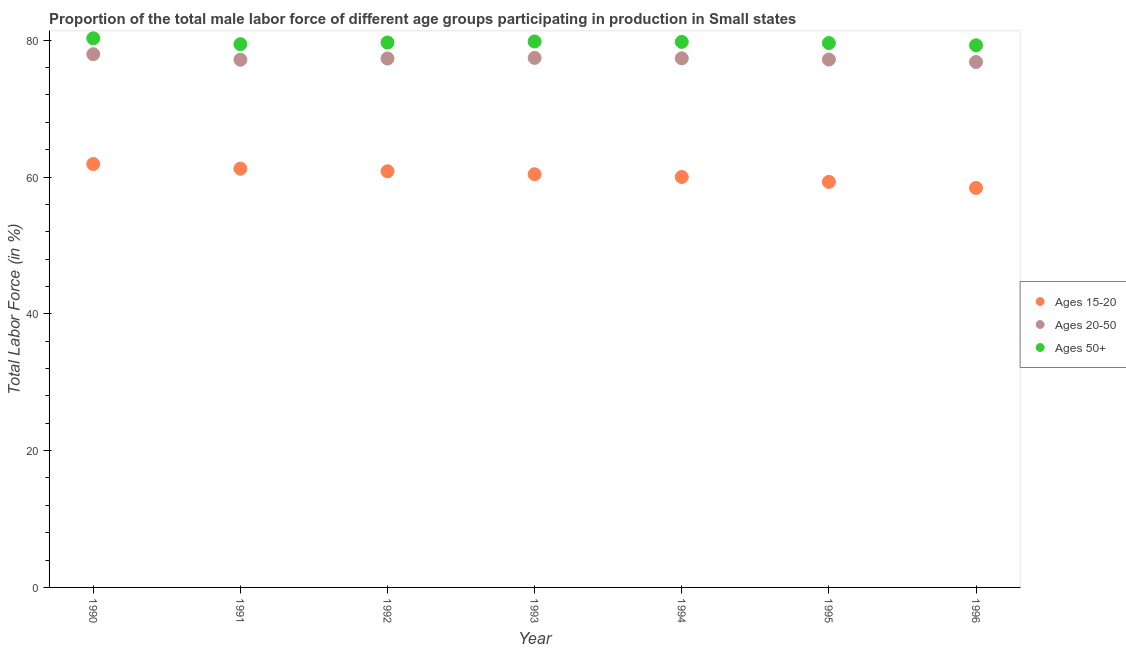What is the percentage of male labor force within the age group 20-50 in 1994?
Give a very brief answer. 77.35. Across all years, what is the maximum percentage of male labor force within the age group 20-50?
Ensure brevity in your answer.  77.96. Across all years, what is the minimum percentage of male labor force above age 50?
Ensure brevity in your answer.  79.26. In which year was the percentage of male labor force within the age group 20-50 minimum?
Your answer should be very brief. 1996. What is the total percentage of male labor force within the age group 20-50 in the graph?
Your response must be concise. 541.21. What is the difference between the percentage of male labor force within the age group 20-50 in 1990 and that in 1995?
Your answer should be compact. 0.78. What is the difference between the percentage of male labor force within the age group 15-20 in 1990 and the percentage of male labor force above age 50 in 1996?
Ensure brevity in your answer.  -17.36. What is the average percentage of male labor force within the age group 15-20 per year?
Your response must be concise. 60.3. In the year 1994, what is the difference between the percentage of male labor force within the age group 20-50 and percentage of male labor force within the age group 15-20?
Your answer should be very brief. 17.34. What is the ratio of the percentage of male labor force within the age group 20-50 in 1992 to that in 1996?
Make the answer very short. 1.01. Is the percentage of male labor force within the age group 15-20 in 1990 less than that in 1993?
Provide a succinct answer. No. What is the difference between the highest and the second highest percentage of male labor force above age 50?
Make the answer very short. 0.46. What is the difference between the highest and the lowest percentage of male labor force within the age group 20-50?
Ensure brevity in your answer.  1.14. How many dotlines are there?
Provide a short and direct response. 3. How many years are there in the graph?
Offer a terse response. 7. How are the legend labels stacked?
Make the answer very short. Vertical. What is the title of the graph?
Offer a terse response. Proportion of the total male labor force of different age groups participating in production in Small states. Does "Ages 20-50" appear as one of the legend labels in the graph?
Provide a short and direct response. Yes. What is the label or title of the X-axis?
Provide a succinct answer. Year. What is the label or title of the Y-axis?
Your answer should be compact. Total Labor Force (in %). What is the Total Labor Force (in %) in Ages 15-20 in 1990?
Offer a very short reply. 61.9. What is the Total Labor Force (in %) in Ages 20-50 in 1990?
Provide a short and direct response. 77.96. What is the Total Labor Force (in %) of Ages 50+ in 1990?
Make the answer very short. 80.28. What is the Total Labor Force (in %) in Ages 15-20 in 1991?
Offer a very short reply. 61.22. What is the Total Labor Force (in %) of Ages 20-50 in 1991?
Ensure brevity in your answer.  77.15. What is the Total Labor Force (in %) in Ages 50+ in 1991?
Offer a terse response. 79.43. What is the Total Labor Force (in %) in Ages 15-20 in 1992?
Give a very brief answer. 60.84. What is the Total Labor Force (in %) of Ages 20-50 in 1992?
Your answer should be compact. 77.33. What is the Total Labor Force (in %) of Ages 50+ in 1992?
Give a very brief answer. 79.66. What is the Total Labor Force (in %) of Ages 15-20 in 1993?
Provide a short and direct response. 60.41. What is the Total Labor Force (in %) in Ages 20-50 in 1993?
Offer a terse response. 77.42. What is the Total Labor Force (in %) in Ages 50+ in 1993?
Ensure brevity in your answer.  79.82. What is the Total Labor Force (in %) in Ages 15-20 in 1994?
Your answer should be very brief. 60.01. What is the Total Labor Force (in %) in Ages 20-50 in 1994?
Ensure brevity in your answer.  77.35. What is the Total Labor Force (in %) in Ages 50+ in 1994?
Provide a succinct answer. 79.76. What is the Total Labor Force (in %) of Ages 15-20 in 1995?
Your response must be concise. 59.29. What is the Total Labor Force (in %) of Ages 20-50 in 1995?
Your answer should be very brief. 77.18. What is the Total Labor Force (in %) in Ages 50+ in 1995?
Make the answer very short. 79.59. What is the Total Labor Force (in %) of Ages 15-20 in 1996?
Give a very brief answer. 58.4. What is the Total Labor Force (in %) in Ages 20-50 in 1996?
Offer a very short reply. 76.82. What is the Total Labor Force (in %) of Ages 50+ in 1996?
Provide a short and direct response. 79.26. Across all years, what is the maximum Total Labor Force (in %) of Ages 15-20?
Ensure brevity in your answer.  61.9. Across all years, what is the maximum Total Labor Force (in %) in Ages 20-50?
Ensure brevity in your answer.  77.96. Across all years, what is the maximum Total Labor Force (in %) of Ages 50+?
Give a very brief answer. 80.28. Across all years, what is the minimum Total Labor Force (in %) of Ages 15-20?
Ensure brevity in your answer.  58.4. Across all years, what is the minimum Total Labor Force (in %) in Ages 20-50?
Provide a succinct answer. 76.82. Across all years, what is the minimum Total Labor Force (in %) in Ages 50+?
Your response must be concise. 79.26. What is the total Total Labor Force (in %) in Ages 15-20 in the graph?
Ensure brevity in your answer.  422.08. What is the total Total Labor Force (in %) of Ages 20-50 in the graph?
Offer a very short reply. 541.21. What is the total Total Labor Force (in %) in Ages 50+ in the graph?
Your response must be concise. 557.8. What is the difference between the Total Labor Force (in %) in Ages 15-20 in 1990 and that in 1991?
Provide a short and direct response. 0.69. What is the difference between the Total Labor Force (in %) in Ages 20-50 in 1990 and that in 1991?
Keep it short and to the point. 0.81. What is the difference between the Total Labor Force (in %) in Ages 50+ in 1990 and that in 1991?
Offer a very short reply. 0.86. What is the difference between the Total Labor Force (in %) in Ages 15-20 in 1990 and that in 1992?
Your response must be concise. 1.06. What is the difference between the Total Labor Force (in %) in Ages 20-50 in 1990 and that in 1992?
Provide a short and direct response. 0.63. What is the difference between the Total Labor Force (in %) of Ages 50+ in 1990 and that in 1992?
Make the answer very short. 0.62. What is the difference between the Total Labor Force (in %) of Ages 15-20 in 1990 and that in 1993?
Provide a short and direct response. 1.5. What is the difference between the Total Labor Force (in %) in Ages 20-50 in 1990 and that in 1993?
Provide a succinct answer. 0.54. What is the difference between the Total Labor Force (in %) in Ages 50+ in 1990 and that in 1993?
Your answer should be very brief. 0.46. What is the difference between the Total Labor Force (in %) of Ages 15-20 in 1990 and that in 1994?
Keep it short and to the point. 1.9. What is the difference between the Total Labor Force (in %) of Ages 20-50 in 1990 and that in 1994?
Provide a short and direct response. 0.61. What is the difference between the Total Labor Force (in %) in Ages 50+ in 1990 and that in 1994?
Give a very brief answer. 0.52. What is the difference between the Total Labor Force (in %) of Ages 15-20 in 1990 and that in 1995?
Your answer should be very brief. 2.61. What is the difference between the Total Labor Force (in %) in Ages 20-50 in 1990 and that in 1995?
Make the answer very short. 0.78. What is the difference between the Total Labor Force (in %) in Ages 50+ in 1990 and that in 1995?
Your response must be concise. 0.69. What is the difference between the Total Labor Force (in %) of Ages 15-20 in 1990 and that in 1996?
Provide a short and direct response. 3.5. What is the difference between the Total Labor Force (in %) in Ages 20-50 in 1990 and that in 1996?
Keep it short and to the point. 1.14. What is the difference between the Total Labor Force (in %) in Ages 50+ in 1990 and that in 1996?
Keep it short and to the point. 1.02. What is the difference between the Total Labor Force (in %) of Ages 15-20 in 1991 and that in 1992?
Give a very brief answer. 0.37. What is the difference between the Total Labor Force (in %) in Ages 20-50 in 1991 and that in 1992?
Make the answer very short. -0.18. What is the difference between the Total Labor Force (in %) of Ages 50+ in 1991 and that in 1992?
Your answer should be compact. -0.24. What is the difference between the Total Labor Force (in %) of Ages 15-20 in 1991 and that in 1993?
Keep it short and to the point. 0.81. What is the difference between the Total Labor Force (in %) in Ages 20-50 in 1991 and that in 1993?
Provide a succinct answer. -0.27. What is the difference between the Total Labor Force (in %) in Ages 50+ in 1991 and that in 1993?
Your answer should be compact. -0.39. What is the difference between the Total Labor Force (in %) of Ages 15-20 in 1991 and that in 1994?
Offer a terse response. 1.21. What is the difference between the Total Labor Force (in %) in Ages 20-50 in 1991 and that in 1994?
Offer a very short reply. -0.2. What is the difference between the Total Labor Force (in %) in Ages 50+ in 1991 and that in 1994?
Give a very brief answer. -0.33. What is the difference between the Total Labor Force (in %) in Ages 15-20 in 1991 and that in 1995?
Provide a short and direct response. 1.93. What is the difference between the Total Labor Force (in %) of Ages 20-50 in 1991 and that in 1995?
Provide a succinct answer. -0.03. What is the difference between the Total Labor Force (in %) of Ages 50+ in 1991 and that in 1995?
Provide a short and direct response. -0.16. What is the difference between the Total Labor Force (in %) in Ages 15-20 in 1991 and that in 1996?
Keep it short and to the point. 2.81. What is the difference between the Total Labor Force (in %) in Ages 20-50 in 1991 and that in 1996?
Your answer should be very brief. 0.33. What is the difference between the Total Labor Force (in %) in Ages 50+ in 1991 and that in 1996?
Give a very brief answer. 0.17. What is the difference between the Total Labor Force (in %) in Ages 15-20 in 1992 and that in 1993?
Your response must be concise. 0.43. What is the difference between the Total Labor Force (in %) of Ages 20-50 in 1992 and that in 1993?
Your answer should be very brief. -0.09. What is the difference between the Total Labor Force (in %) of Ages 50+ in 1992 and that in 1993?
Your answer should be very brief. -0.15. What is the difference between the Total Labor Force (in %) in Ages 15-20 in 1992 and that in 1994?
Give a very brief answer. 0.83. What is the difference between the Total Labor Force (in %) in Ages 20-50 in 1992 and that in 1994?
Offer a terse response. -0.02. What is the difference between the Total Labor Force (in %) of Ages 50+ in 1992 and that in 1994?
Your answer should be compact. -0.09. What is the difference between the Total Labor Force (in %) in Ages 15-20 in 1992 and that in 1995?
Make the answer very short. 1.55. What is the difference between the Total Labor Force (in %) in Ages 20-50 in 1992 and that in 1995?
Give a very brief answer. 0.15. What is the difference between the Total Labor Force (in %) in Ages 50+ in 1992 and that in 1995?
Provide a short and direct response. 0.08. What is the difference between the Total Labor Force (in %) of Ages 15-20 in 1992 and that in 1996?
Give a very brief answer. 2.44. What is the difference between the Total Labor Force (in %) of Ages 20-50 in 1992 and that in 1996?
Ensure brevity in your answer.  0.51. What is the difference between the Total Labor Force (in %) in Ages 50+ in 1992 and that in 1996?
Provide a short and direct response. 0.41. What is the difference between the Total Labor Force (in %) in Ages 15-20 in 1993 and that in 1994?
Offer a very short reply. 0.4. What is the difference between the Total Labor Force (in %) in Ages 20-50 in 1993 and that in 1994?
Keep it short and to the point. 0.07. What is the difference between the Total Labor Force (in %) in Ages 50+ in 1993 and that in 1994?
Make the answer very short. 0.06. What is the difference between the Total Labor Force (in %) in Ages 15-20 in 1993 and that in 1995?
Ensure brevity in your answer.  1.12. What is the difference between the Total Labor Force (in %) of Ages 20-50 in 1993 and that in 1995?
Make the answer very short. 0.24. What is the difference between the Total Labor Force (in %) of Ages 50+ in 1993 and that in 1995?
Offer a terse response. 0.23. What is the difference between the Total Labor Force (in %) in Ages 15-20 in 1993 and that in 1996?
Provide a short and direct response. 2.01. What is the difference between the Total Labor Force (in %) of Ages 20-50 in 1993 and that in 1996?
Offer a terse response. 0.6. What is the difference between the Total Labor Force (in %) of Ages 50+ in 1993 and that in 1996?
Provide a succinct answer. 0.56. What is the difference between the Total Labor Force (in %) of Ages 15-20 in 1994 and that in 1995?
Your answer should be very brief. 0.72. What is the difference between the Total Labor Force (in %) in Ages 20-50 in 1994 and that in 1995?
Your response must be concise. 0.17. What is the difference between the Total Labor Force (in %) of Ages 50+ in 1994 and that in 1995?
Offer a very short reply. 0.17. What is the difference between the Total Labor Force (in %) of Ages 15-20 in 1994 and that in 1996?
Your answer should be compact. 1.61. What is the difference between the Total Labor Force (in %) of Ages 20-50 in 1994 and that in 1996?
Your answer should be very brief. 0.53. What is the difference between the Total Labor Force (in %) of Ages 50+ in 1994 and that in 1996?
Your response must be concise. 0.5. What is the difference between the Total Labor Force (in %) in Ages 15-20 in 1995 and that in 1996?
Offer a terse response. 0.89. What is the difference between the Total Labor Force (in %) in Ages 20-50 in 1995 and that in 1996?
Ensure brevity in your answer.  0.36. What is the difference between the Total Labor Force (in %) of Ages 50+ in 1995 and that in 1996?
Make the answer very short. 0.33. What is the difference between the Total Labor Force (in %) of Ages 15-20 in 1990 and the Total Labor Force (in %) of Ages 20-50 in 1991?
Your answer should be compact. -15.25. What is the difference between the Total Labor Force (in %) in Ages 15-20 in 1990 and the Total Labor Force (in %) in Ages 50+ in 1991?
Your answer should be compact. -17.52. What is the difference between the Total Labor Force (in %) of Ages 20-50 in 1990 and the Total Labor Force (in %) of Ages 50+ in 1991?
Ensure brevity in your answer.  -1.47. What is the difference between the Total Labor Force (in %) in Ages 15-20 in 1990 and the Total Labor Force (in %) in Ages 20-50 in 1992?
Provide a short and direct response. -15.42. What is the difference between the Total Labor Force (in %) of Ages 15-20 in 1990 and the Total Labor Force (in %) of Ages 50+ in 1992?
Your response must be concise. -17.76. What is the difference between the Total Labor Force (in %) in Ages 20-50 in 1990 and the Total Labor Force (in %) in Ages 50+ in 1992?
Provide a succinct answer. -1.71. What is the difference between the Total Labor Force (in %) of Ages 15-20 in 1990 and the Total Labor Force (in %) of Ages 20-50 in 1993?
Provide a short and direct response. -15.51. What is the difference between the Total Labor Force (in %) in Ages 15-20 in 1990 and the Total Labor Force (in %) in Ages 50+ in 1993?
Offer a very short reply. -17.91. What is the difference between the Total Labor Force (in %) in Ages 20-50 in 1990 and the Total Labor Force (in %) in Ages 50+ in 1993?
Offer a terse response. -1.86. What is the difference between the Total Labor Force (in %) of Ages 15-20 in 1990 and the Total Labor Force (in %) of Ages 20-50 in 1994?
Offer a very short reply. -15.45. What is the difference between the Total Labor Force (in %) in Ages 15-20 in 1990 and the Total Labor Force (in %) in Ages 50+ in 1994?
Keep it short and to the point. -17.85. What is the difference between the Total Labor Force (in %) in Ages 20-50 in 1990 and the Total Labor Force (in %) in Ages 50+ in 1994?
Provide a succinct answer. -1.8. What is the difference between the Total Labor Force (in %) of Ages 15-20 in 1990 and the Total Labor Force (in %) of Ages 20-50 in 1995?
Ensure brevity in your answer.  -15.28. What is the difference between the Total Labor Force (in %) of Ages 15-20 in 1990 and the Total Labor Force (in %) of Ages 50+ in 1995?
Provide a succinct answer. -17.69. What is the difference between the Total Labor Force (in %) in Ages 20-50 in 1990 and the Total Labor Force (in %) in Ages 50+ in 1995?
Your response must be concise. -1.63. What is the difference between the Total Labor Force (in %) of Ages 15-20 in 1990 and the Total Labor Force (in %) of Ages 20-50 in 1996?
Offer a terse response. -14.92. What is the difference between the Total Labor Force (in %) of Ages 15-20 in 1990 and the Total Labor Force (in %) of Ages 50+ in 1996?
Provide a succinct answer. -17.36. What is the difference between the Total Labor Force (in %) of Ages 20-50 in 1990 and the Total Labor Force (in %) of Ages 50+ in 1996?
Provide a succinct answer. -1.3. What is the difference between the Total Labor Force (in %) of Ages 15-20 in 1991 and the Total Labor Force (in %) of Ages 20-50 in 1992?
Make the answer very short. -16.11. What is the difference between the Total Labor Force (in %) in Ages 15-20 in 1991 and the Total Labor Force (in %) in Ages 50+ in 1992?
Provide a succinct answer. -18.45. What is the difference between the Total Labor Force (in %) in Ages 20-50 in 1991 and the Total Labor Force (in %) in Ages 50+ in 1992?
Provide a succinct answer. -2.51. What is the difference between the Total Labor Force (in %) in Ages 15-20 in 1991 and the Total Labor Force (in %) in Ages 20-50 in 1993?
Your answer should be very brief. -16.2. What is the difference between the Total Labor Force (in %) in Ages 15-20 in 1991 and the Total Labor Force (in %) in Ages 50+ in 1993?
Keep it short and to the point. -18.6. What is the difference between the Total Labor Force (in %) in Ages 20-50 in 1991 and the Total Labor Force (in %) in Ages 50+ in 1993?
Provide a succinct answer. -2.67. What is the difference between the Total Labor Force (in %) of Ages 15-20 in 1991 and the Total Labor Force (in %) of Ages 20-50 in 1994?
Offer a very short reply. -16.13. What is the difference between the Total Labor Force (in %) of Ages 15-20 in 1991 and the Total Labor Force (in %) of Ages 50+ in 1994?
Keep it short and to the point. -18.54. What is the difference between the Total Labor Force (in %) of Ages 20-50 in 1991 and the Total Labor Force (in %) of Ages 50+ in 1994?
Keep it short and to the point. -2.61. What is the difference between the Total Labor Force (in %) of Ages 15-20 in 1991 and the Total Labor Force (in %) of Ages 20-50 in 1995?
Your answer should be compact. -15.96. What is the difference between the Total Labor Force (in %) of Ages 15-20 in 1991 and the Total Labor Force (in %) of Ages 50+ in 1995?
Keep it short and to the point. -18.37. What is the difference between the Total Labor Force (in %) of Ages 20-50 in 1991 and the Total Labor Force (in %) of Ages 50+ in 1995?
Your answer should be very brief. -2.44. What is the difference between the Total Labor Force (in %) in Ages 15-20 in 1991 and the Total Labor Force (in %) in Ages 20-50 in 1996?
Make the answer very short. -15.6. What is the difference between the Total Labor Force (in %) of Ages 15-20 in 1991 and the Total Labor Force (in %) of Ages 50+ in 1996?
Give a very brief answer. -18.04. What is the difference between the Total Labor Force (in %) of Ages 20-50 in 1991 and the Total Labor Force (in %) of Ages 50+ in 1996?
Offer a very short reply. -2.11. What is the difference between the Total Labor Force (in %) in Ages 15-20 in 1992 and the Total Labor Force (in %) in Ages 20-50 in 1993?
Provide a succinct answer. -16.58. What is the difference between the Total Labor Force (in %) of Ages 15-20 in 1992 and the Total Labor Force (in %) of Ages 50+ in 1993?
Provide a succinct answer. -18.98. What is the difference between the Total Labor Force (in %) of Ages 20-50 in 1992 and the Total Labor Force (in %) of Ages 50+ in 1993?
Offer a terse response. -2.49. What is the difference between the Total Labor Force (in %) in Ages 15-20 in 1992 and the Total Labor Force (in %) in Ages 20-50 in 1994?
Ensure brevity in your answer.  -16.51. What is the difference between the Total Labor Force (in %) of Ages 15-20 in 1992 and the Total Labor Force (in %) of Ages 50+ in 1994?
Your answer should be very brief. -18.92. What is the difference between the Total Labor Force (in %) of Ages 20-50 in 1992 and the Total Labor Force (in %) of Ages 50+ in 1994?
Your answer should be compact. -2.43. What is the difference between the Total Labor Force (in %) in Ages 15-20 in 1992 and the Total Labor Force (in %) in Ages 20-50 in 1995?
Provide a succinct answer. -16.34. What is the difference between the Total Labor Force (in %) of Ages 15-20 in 1992 and the Total Labor Force (in %) of Ages 50+ in 1995?
Provide a short and direct response. -18.75. What is the difference between the Total Labor Force (in %) in Ages 20-50 in 1992 and the Total Labor Force (in %) in Ages 50+ in 1995?
Provide a succinct answer. -2.26. What is the difference between the Total Labor Force (in %) of Ages 15-20 in 1992 and the Total Labor Force (in %) of Ages 20-50 in 1996?
Your answer should be compact. -15.98. What is the difference between the Total Labor Force (in %) of Ages 15-20 in 1992 and the Total Labor Force (in %) of Ages 50+ in 1996?
Your answer should be compact. -18.42. What is the difference between the Total Labor Force (in %) of Ages 20-50 in 1992 and the Total Labor Force (in %) of Ages 50+ in 1996?
Provide a short and direct response. -1.93. What is the difference between the Total Labor Force (in %) in Ages 15-20 in 1993 and the Total Labor Force (in %) in Ages 20-50 in 1994?
Make the answer very short. -16.94. What is the difference between the Total Labor Force (in %) in Ages 15-20 in 1993 and the Total Labor Force (in %) in Ages 50+ in 1994?
Ensure brevity in your answer.  -19.35. What is the difference between the Total Labor Force (in %) in Ages 20-50 in 1993 and the Total Labor Force (in %) in Ages 50+ in 1994?
Your response must be concise. -2.34. What is the difference between the Total Labor Force (in %) in Ages 15-20 in 1993 and the Total Labor Force (in %) in Ages 20-50 in 1995?
Offer a very short reply. -16.77. What is the difference between the Total Labor Force (in %) of Ages 15-20 in 1993 and the Total Labor Force (in %) of Ages 50+ in 1995?
Offer a very short reply. -19.18. What is the difference between the Total Labor Force (in %) of Ages 20-50 in 1993 and the Total Labor Force (in %) of Ages 50+ in 1995?
Offer a very short reply. -2.17. What is the difference between the Total Labor Force (in %) in Ages 15-20 in 1993 and the Total Labor Force (in %) in Ages 20-50 in 1996?
Your answer should be very brief. -16.41. What is the difference between the Total Labor Force (in %) of Ages 15-20 in 1993 and the Total Labor Force (in %) of Ages 50+ in 1996?
Offer a terse response. -18.85. What is the difference between the Total Labor Force (in %) of Ages 20-50 in 1993 and the Total Labor Force (in %) of Ages 50+ in 1996?
Ensure brevity in your answer.  -1.84. What is the difference between the Total Labor Force (in %) of Ages 15-20 in 1994 and the Total Labor Force (in %) of Ages 20-50 in 1995?
Your answer should be very brief. -17.17. What is the difference between the Total Labor Force (in %) in Ages 15-20 in 1994 and the Total Labor Force (in %) in Ages 50+ in 1995?
Offer a very short reply. -19.58. What is the difference between the Total Labor Force (in %) in Ages 20-50 in 1994 and the Total Labor Force (in %) in Ages 50+ in 1995?
Offer a very short reply. -2.24. What is the difference between the Total Labor Force (in %) of Ages 15-20 in 1994 and the Total Labor Force (in %) of Ages 20-50 in 1996?
Offer a terse response. -16.81. What is the difference between the Total Labor Force (in %) of Ages 15-20 in 1994 and the Total Labor Force (in %) of Ages 50+ in 1996?
Provide a succinct answer. -19.25. What is the difference between the Total Labor Force (in %) of Ages 20-50 in 1994 and the Total Labor Force (in %) of Ages 50+ in 1996?
Provide a short and direct response. -1.91. What is the difference between the Total Labor Force (in %) of Ages 15-20 in 1995 and the Total Labor Force (in %) of Ages 20-50 in 1996?
Ensure brevity in your answer.  -17.53. What is the difference between the Total Labor Force (in %) in Ages 15-20 in 1995 and the Total Labor Force (in %) in Ages 50+ in 1996?
Keep it short and to the point. -19.97. What is the difference between the Total Labor Force (in %) of Ages 20-50 in 1995 and the Total Labor Force (in %) of Ages 50+ in 1996?
Offer a terse response. -2.08. What is the average Total Labor Force (in %) in Ages 15-20 per year?
Your answer should be very brief. 60.3. What is the average Total Labor Force (in %) of Ages 20-50 per year?
Your response must be concise. 77.32. What is the average Total Labor Force (in %) in Ages 50+ per year?
Provide a short and direct response. 79.69. In the year 1990, what is the difference between the Total Labor Force (in %) in Ages 15-20 and Total Labor Force (in %) in Ages 20-50?
Give a very brief answer. -16.05. In the year 1990, what is the difference between the Total Labor Force (in %) of Ages 15-20 and Total Labor Force (in %) of Ages 50+?
Your answer should be compact. -18.38. In the year 1990, what is the difference between the Total Labor Force (in %) of Ages 20-50 and Total Labor Force (in %) of Ages 50+?
Your answer should be very brief. -2.33. In the year 1991, what is the difference between the Total Labor Force (in %) in Ages 15-20 and Total Labor Force (in %) in Ages 20-50?
Make the answer very short. -15.93. In the year 1991, what is the difference between the Total Labor Force (in %) in Ages 15-20 and Total Labor Force (in %) in Ages 50+?
Offer a terse response. -18.21. In the year 1991, what is the difference between the Total Labor Force (in %) of Ages 20-50 and Total Labor Force (in %) of Ages 50+?
Provide a short and direct response. -2.27. In the year 1992, what is the difference between the Total Labor Force (in %) of Ages 15-20 and Total Labor Force (in %) of Ages 20-50?
Provide a succinct answer. -16.49. In the year 1992, what is the difference between the Total Labor Force (in %) of Ages 15-20 and Total Labor Force (in %) of Ages 50+?
Give a very brief answer. -18.82. In the year 1992, what is the difference between the Total Labor Force (in %) in Ages 20-50 and Total Labor Force (in %) in Ages 50+?
Offer a very short reply. -2.34. In the year 1993, what is the difference between the Total Labor Force (in %) of Ages 15-20 and Total Labor Force (in %) of Ages 20-50?
Ensure brevity in your answer.  -17.01. In the year 1993, what is the difference between the Total Labor Force (in %) in Ages 15-20 and Total Labor Force (in %) in Ages 50+?
Provide a short and direct response. -19.41. In the year 1993, what is the difference between the Total Labor Force (in %) in Ages 20-50 and Total Labor Force (in %) in Ages 50+?
Offer a terse response. -2.4. In the year 1994, what is the difference between the Total Labor Force (in %) of Ages 15-20 and Total Labor Force (in %) of Ages 20-50?
Your response must be concise. -17.34. In the year 1994, what is the difference between the Total Labor Force (in %) in Ages 15-20 and Total Labor Force (in %) in Ages 50+?
Provide a succinct answer. -19.75. In the year 1994, what is the difference between the Total Labor Force (in %) in Ages 20-50 and Total Labor Force (in %) in Ages 50+?
Make the answer very short. -2.41. In the year 1995, what is the difference between the Total Labor Force (in %) in Ages 15-20 and Total Labor Force (in %) in Ages 20-50?
Ensure brevity in your answer.  -17.89. In the year 1995, what is the difference between the Total Labor Force (in %) of Ages 15-20 and Total Labor Force (in %) of Ages 50+?
Provide a short and direct response. -20.3. In the year 1995, what is the difference between the Total Labor Force (in %) of Ages 20-50 and Total Labor Force (in %) of Ages 50+?
Ensure brevity in your answer.  -2.41. In the year 1996, what is the difference between the Total Labor Force (in %) of Ages 15-20 and Total Labor Force (in %) of Ages 20-50?
Offer a terse response. -18.42. In the year 1996, what is the difference between the Total Labor Force (in %) in Ages 15-20 and Total Labor Force (in %) in Ages 50+?
Your answer should be very brief. -20.86. In the year 1996, what is the difference between the Total Labor Force (in %) in Ages 20-50 and Total Labor Force (in %) in Ages 50+?
Offer a very short reply. -2.44. What is the ratio of the Total Labor Force (in %) of Ages 15-20 in 1990 to that in 1991?
Make the answer very short. 1.01. What is the ratio of the Total Labor Force (in %) in Ages 20-50 in 1990 to that in 1991?
Provide a succinct answer. 1.01. What is the ratio of the Total Labor Force (in %) of Ages 50+ in 1990 to that in 1991?
Give a very brief answer. 1.01. What is the ratio of the Total Labor Force (in %) in Ages 15-20 in 1990 to that in 1992?
Offer a very short reply. 1.02. What is the ratio of the Total Labor Force (in %) of Ages 50+ in 1990 to that in 1992?
Give a very brief answer. 1.01. What is the ratio of the Total Labor Force (in %) of Ages 15-20 in 1990 to that in 1993?
Give a very brief answer. 1.02. What is the ratio of the Total Labor Force (in %) in Ages 20-50 in 1990 to that in 1993?
Offer a terse response. 1.01. What is the ratio of the Total Labor Force (in %) of Ages 15-20 in 1990 to that in 1994?
Ensure brevity in your answer.  1.03. What is the ratio of the Total Labor Force (in %) in Ages 20-50 in 1990 to that in 1994?
Provide a succinct answer. 1.01. What is the ratio of the Total Labor Force (in %) of Ages 50+ in 1990 to that in 1994?
Your answer should be compact. 1.01. What is the ratio of the Total Labor Force (in %) in Ages 15-20 in 1990 to that in 1995?
Your response must be concise. 1.04. What is the ratio of the Total Labor Force (in %) of Ages 20-50 in 1990 to that in 1995?
Provide a succinct answer. 1.01. What is the ratio of the Total Labor Force (in %) of Ages 50+ in 1990 to that in 1995?
Your answer should be very brief. 1.01. What is the ratio of the Total Labor Force (in %) of Ages 15-20 in 1990 to that in 1996?
Your answer should be compact. 1.06. What is the ratio of the Total Labor Force (in %) in Ages 20-50 in 1990 to that in 1996?
Offer a terse response. 1.01. What is the ratio of the Total Labor Force (in %) in Ages 50+ in 1990 to that in 1996?
Provide a succinct answer. 1.01. What is the ratio of the Total Labor Force (in %) of Ages 15-20 in 1991 to that in 1992?
Your answer should be compact. 1.01. What is the ratio of the Total Labor Force (in %) of Ages 20-50 in 1991 to that in 1992?
Provide a short and direct response. 1. What is the ratio of the Total Labor Force (in %) in Ages 50+ in 1991 to that in 1992?
Give a very brief answer. 1. What is the ratio of the Total Labor Force (in %) in Ages 15-20 in 1991 to that in 1993?
Ensure brevity in your answer.  1.01. What is the ratio of the Total Labor Force (in %) in Ages 20-50 in 1991 to that in 1993?
Your answer should be very brief. 1. What is the ratio of the Total Labor Force (in %) in Ages 50+ in 1991 to that in 1993?
Your answer should be very brief. 1. What is the ratio of the Total Labor Force (in %) of Ages 15-20 in 1991 to that in 1994?
Offer a terse response. 1.02. What is the ratio of the Total Labor Force (in %) of Ages 20-50 in 1991 to that in 1994?
Provide a succinct answer. 1. What is the ratio of the Total Labor Force (in %) of Ages 15-20 in 1991 to that in 1995?
Your response must be concise. 1.03. What is the ratio of the Total Labor Force (in %) in Ages 15-20 in 1991 to that in 1996?
Your answer should be compact. 1.05. What is the ratio of the Total Labor Force (in %) of Ages 20-50 in 1991 to that in 1996?
Your answer should be compact. 1. What is the ratio of the Total Labor Force (in %) in Ages 15-20 in 1992 to that in 1993?
Keep it short and to the point. 1.01. What is the ratio of the Total Labor Force (in %) in Ages 20-50 in 1992 to that in 1993?
Offer a terse response. 1. What is the ratio of the Total Labor Force (in %) in Ages 50+ in 1992 to that in 1993?
Provide a short and direct response. 1. What is the ratio of the Total Labor Force (in %) of Ages 15-20 in 1992 to that in 1994?
Ensure brevity in your answer.  1.01. What is the ratio of the Total Labor Force (in %) in Ages 20-50 in 1992 to that in 1994?
Your answer should be very brief. 1. What is the ratio of the Total Labor Force (in %) in Ages 15-20 in 1992 to that in 1995?
Your answer should be compact. 1.03. What is the ratio of the Total Labor Force (in %) in Ages 20-50 in 1992 to that in 1995?
Make the answer very short. 1. What is the ratio of the Total Labor Force (in %) of Ages 50+ in 1992 to that in 1995?
Your answer should be compact. 1. What is the ratio of the Total Labor Force (in %) in Ages 15-20 in 1992 to that in 1996?
Offer a terse response. 1.04. What is the ratio of the Total Labor Force (in %) of Ages 20-50 in 1992 to that in 1996?
Give a very brief answer. 1.01. What is the ratio of the Total Labor Force (in %) in Ages 50+ in 1992 to that in 1996?
Provide a short and direct response. 1.01. What is the ratio of the Total Labor Force (in %) of Ages 20-50 in 1993 to that in 1994?
Offer a very short reply. 1. What is the ratio of the Total Labor Force (in %) of Ages 50+ in 1993 to that in 1994?
Provide a succinct answer. 1. What is the ratio of the Total Labor Force (in %) of Ages 15-20 in 1993 to that in 1995?
Give a very brief answer. 1.02. What is the ratio of the Total Labor Force (in %) of Ages 50+ in 1993 to that in 1995?
Your answer should be compact. 1. What is the ratio of the Total Labor Force (in %) in Ages 15-20 in 1993 to that in 1996?
Offer a very short reply. 1.03. What is the ratio of the Total Labor Force (in %) of Ages 50+ in 1993 to that in 1996?
Keep it short and to the point. 1.01. What is the ratio of the Total Labor Force (in %) in Ages 15-20 in 1994 to that in 1995?
Provide a short and direct response. 1.01. What is the ratio of the Total Labor Force (in %) of Ages 20-50 in 1994 to that in 1995?
Your response must be concise. 1. What is the ratio of the Total Labor Force (in %) in Ages 50+ in 1994 to that in 1995?
Give a very brief answer. 1. What is the ratio of the Total Labor Force (in %) in Ages 15-20 in 1994 to that in 1996?
Provide a succinct answer. 1.03. What is the ratio of the Total Labor Force (in %) of Ages 15-20 in 1995 to that in 1996?
Keep it short and to the point. 1.02. What is the difference between the highest and the second highest Total Labor Force (in %) of Ages 15-20?
Offer a terse response. 0.69. What is the difference between the highest and the second highest Total Labor Force (in %) in Ages 20-50?
Ensure brevity in your answer.  0.54. What is the difference between the highest and the second highest Total Labor Force (in %) in Ages 50+?
Your response must be concise. 0.46. What is the difference between the highest and the lowest Total Labor Force (in %) of Ages 15-20?
Your answer should be very brief. 3.5. What is the difference between the highest and the lowest Total Labor Force (in %) in Ages 20-50?
Your answer should be compact. 1.14. What is the difference between the highest and the lowest Total Labor Force (in %) of Ages 50+?
Offer a terse response. 1.02. 